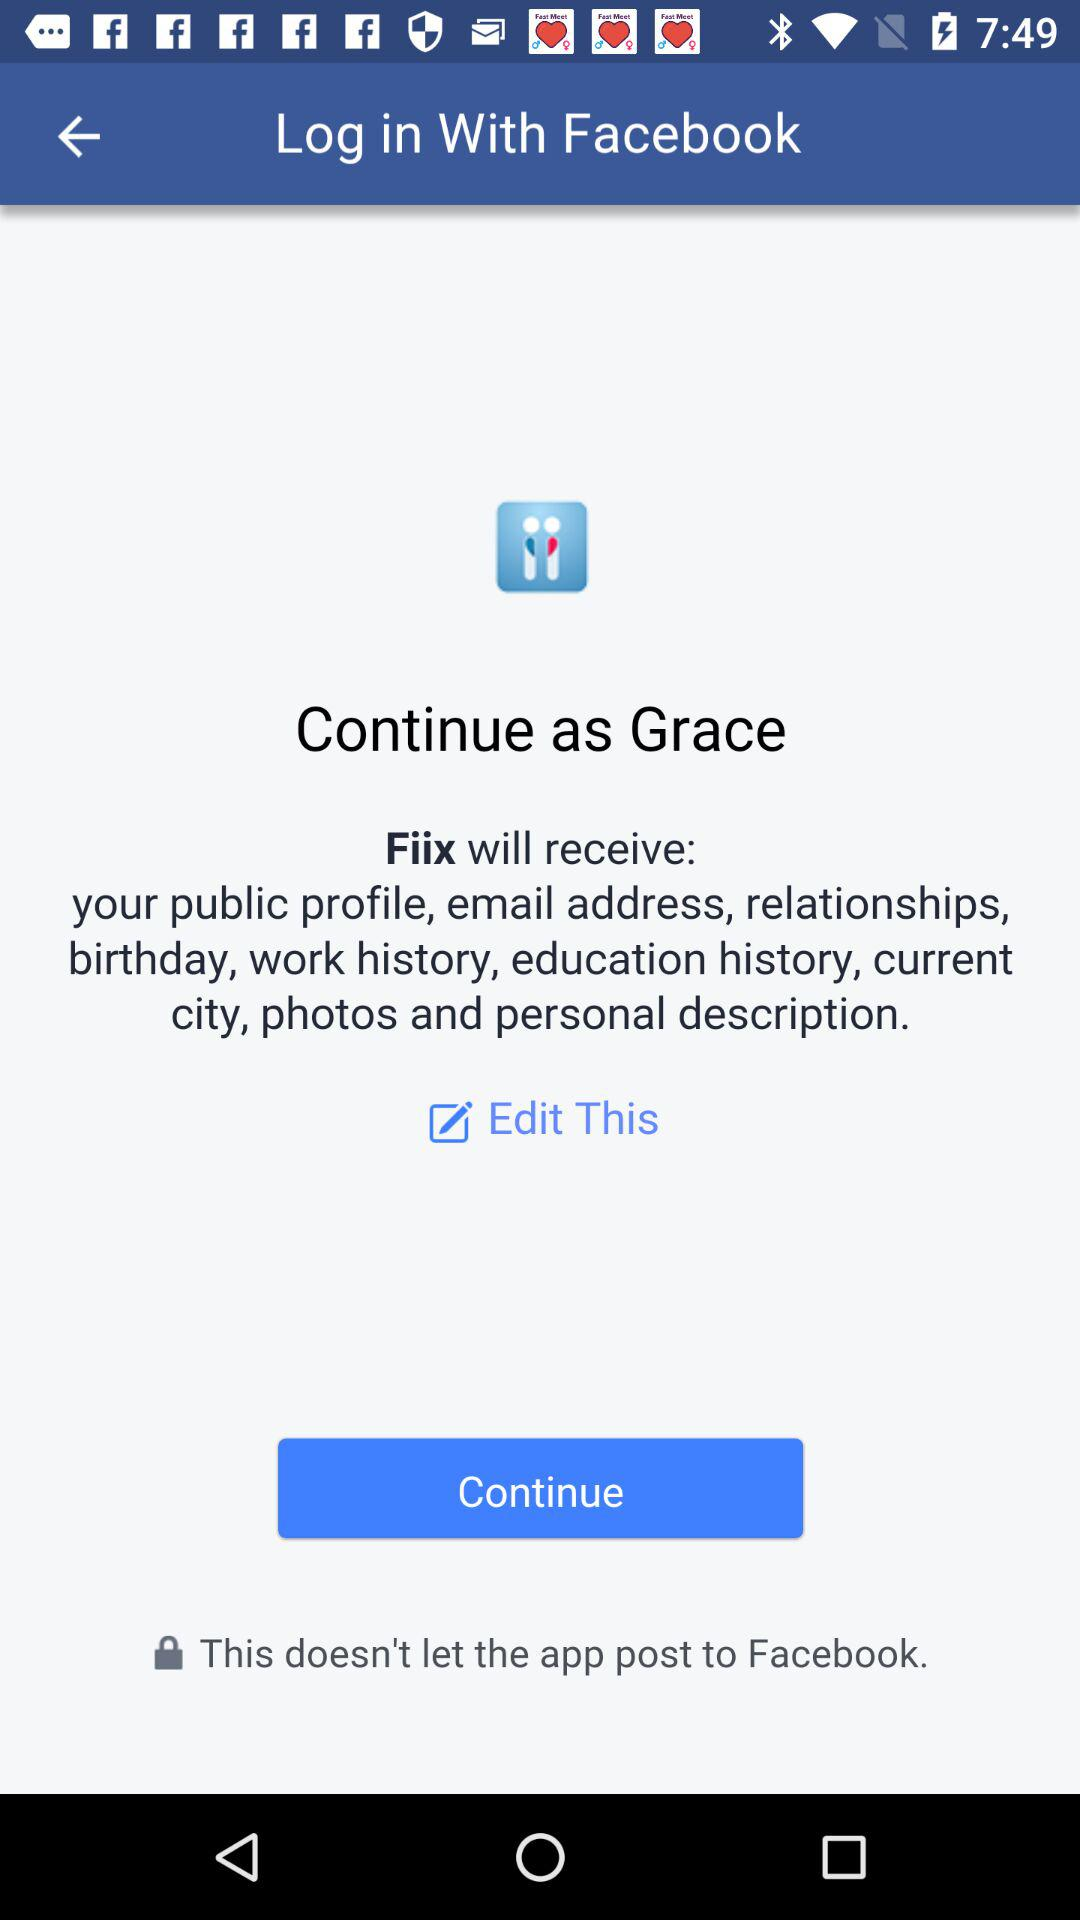What application is asking for permission? The application that is asking for permission is "Fiix". 